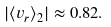Convert formula to latex. <formula><loc_0><loc_0><loc_500><loc_500>| \langle v _ { r } \rangle _ { 2 } | \approx 0 . 8 2 .</formula> 